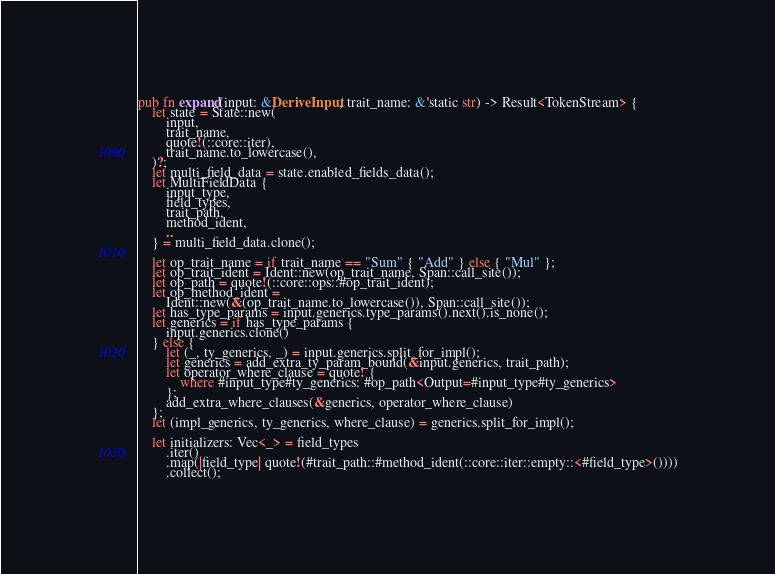<code> <loc_0><loc_0><loc_500><loc_500><_Rust_>
pub fn expand(input: &DeriveInput, trait_name: &'static str) -> Result<TokenStream> {
    let state = State::new(
        input,
        trait_name,
        quote!(::core::iter),
        trait_name.to_lowercase(),
    )?;
    let multi_field_data = state.enabled_fields_data();
    let MultiFieldData {
        input_type,
        field_types,
        trait_path,
        method_ident,
        ..
    } = multi_field_data.clone();

    let op_trait_name = if trait_name == "Sum" { "Add" } else { "Mul" };
    let op_trait_ident = Ident::new(op_trait_name, Span::call_site());
    let op_path = quote!(::core::ops::#op_trait_ident);
    let op_method_ident =
        Ident::new(&(op_trait_name.to_lowercase()), Span::call_site());
    let has_type_params = input.generics.type_params().next().is_none();
    let generics = if has_type_params {
        input.generics.clone()
    } else {
        let (_, ty_generics, _) = input.generics.split_for_impl();
        let generics = add_extra_ty_param_bound(&input.generics, trait_path);
        let operator_where_clause = quote! {
            where #input_type#ty_generics: #op_path<Output=#input_type#ty_generics>
        };
        add_extra_where_clauses(&generics, operator_where_clause)
    };
    let (impl_generics, ty_generics, where_clause) = generics.split_for_impl();

    let initializers: Vec<_> = field_types
        .iter()
        .map(|field_type| quote!(#trait_path::#method_ident(::core::iter::empty::<#field_type>())))
        .collect();</code> 